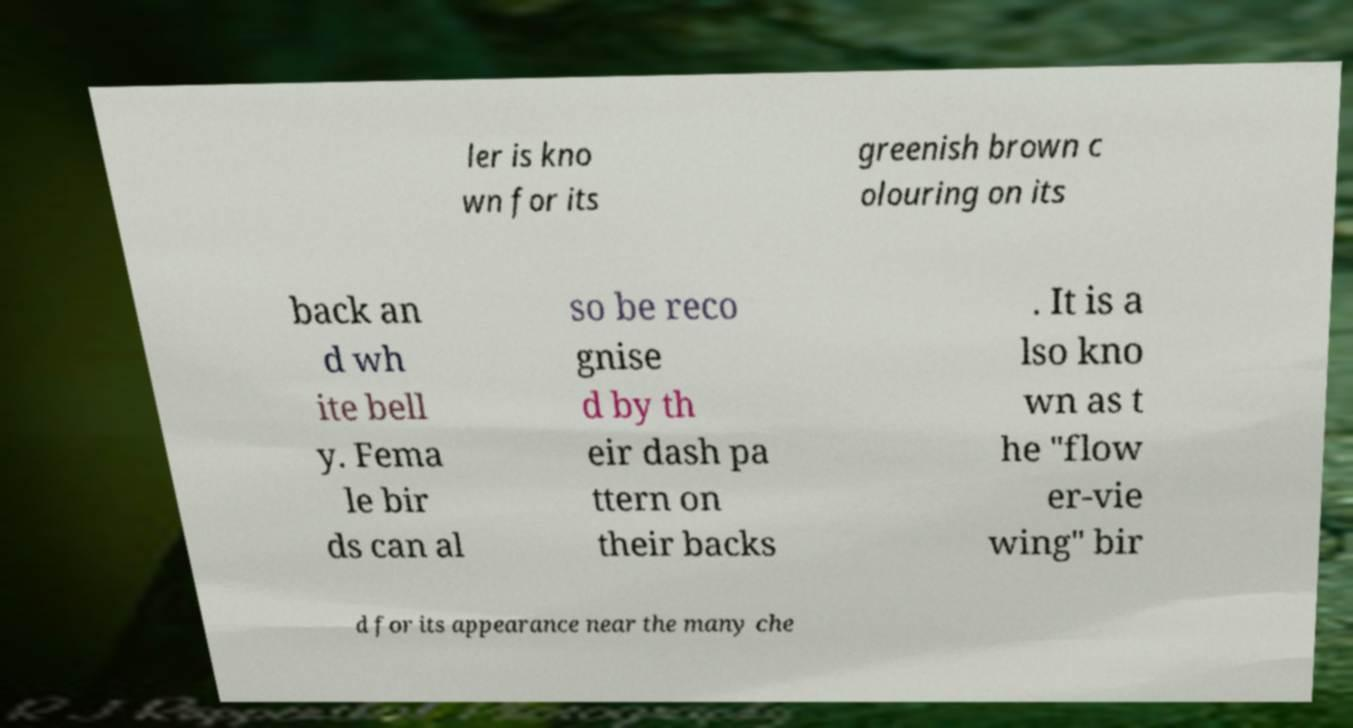Could you assist in decoding the text presented in this image and type it out clearly? ler is kno wn for its greenish brown c olouring on its back an d wh ite bell y. Fema le bir ds can al so be reco gnise d by th eir dash pa ttern on their backs . It is a lso kno wn as t he "flow er-vie wing" bir d for its appearance near the many che 